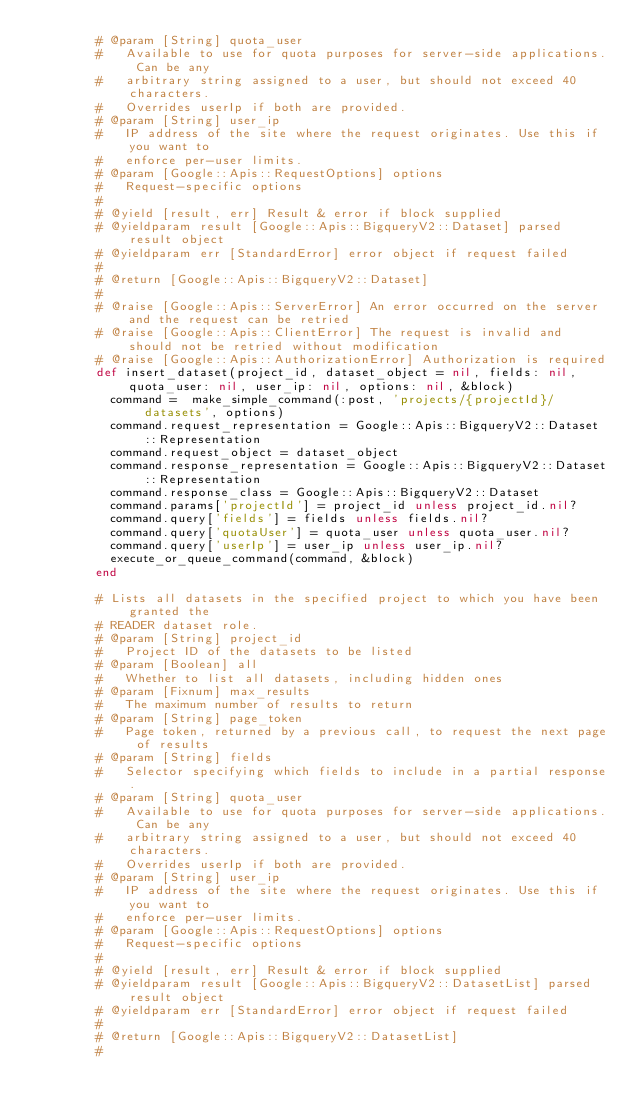<code> <loc_0><loc_0><loc_500><loc_500><_Ruby_>        # @param [String] quota_user
        #   Available to use for quota purposes for server-side applications. Can be any
        #   arbitrary string assigned to a user, but should not exceed 40 characters.
        #   Overrides userIp if both are provided.
        # @param [String] user_ip
        #   IP address of the site where the request originates. Use this if you want to
        #   enforce per-user limits.
        # @param [Google::Apis::RequestOptions] options
        #   Request-specific options
        #
        # @yield [result, err] Result & error if block supplied
        # @yieldparam result [Google::Apis::BigqueryV2::Dataset] parsed result object
        # @yieldparam err [StandardError] error object if request failed
        #
        # @return [Google::Apis::BigqueryV2::Dataset]
        #
        # @raise [Google::Apis::ServerError] An error occurred on the server and the request can be retried
        # @raise [Google::Apis::ClientError] The request is invalid and should not be retried without modification
        # @raise [Google::Apis::AuthorizationError] Authorization is required
        def insert_dataset(project_id, dataset_object = nil, fields: nil, quota_user: nil, user_ip: nil, options: nil, &block)
          command =  make_simple_command(:post, 'projects/{projectId}/datasets', options)
          command.request_representation = Google::Apis::BigqueryV2::Dataset::Representation
          command.request_object = dataset_object
          command.response_representation = Google::Apis::BigqueryV2::Dataset::Representation
          command.response_class = Google::Apis::BigqueryV2::Dataset
          command.params['projectId'] = project_id unless project_id.nil?
          command.query['fields'] = fields unless fields.nil?
          command.query['quotaUser'] = quota_user unless quota_user.nil?
          command.query['userIp'] = user_ip unless user_ip.nil?
          execute_or_queue_command(command, &block)
        end
        
        # Lists all datasets in the specified project to which you have been granted the
        # READER dataset role.
        # @param [String] project_id
        #   Project ID of the datasets to be listed
        # @param [Boolean] all
        #   Whether to list all datasets, including hidden ones
        # @param [Fixnum] max_results
        #   The maximum number of results to return
        # @param [String] page_token
        #   Page token, returned by a previous call, to request the next page of results
        # @param [String] fields
        #   Selector specifying which fields to include in a partial response.
        # @param [String] quota_user
        #   Available to use for quota purposes for server-side applications. Can be any
        #   arbitrary string assigned to a user, but should not exceed 40 characters.
        #   Overrides userIp if both are provided.
        # @param [String] user_ip
        #   IP address of the site where the request originates. Use this if you want to
        #   enforce per-user limits.
        # @param [Google::Apis::RequestOptions] options
        #   Request-specific options
        #
        # @yield [result, err] Result & error if block supplied
        # @yieldparam result [Google::Apis::BigqueryV2::DatasetList] parsed result object
        # @yieldparam err [StandardError] error object if request failed
        #
        # @return [Google::Apis::BigqueryV2::DatasetList]
        #</code> 